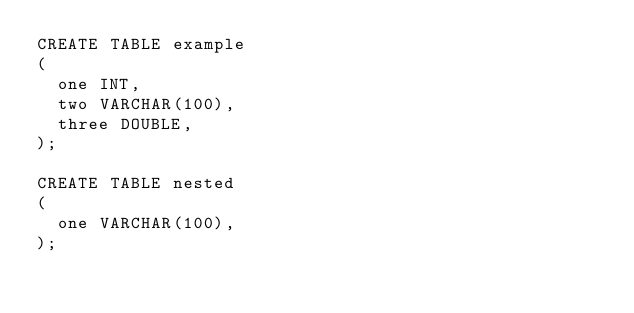Convert code to text. <code><loc_0><loc_0><loc_500><loc_500><_SQL_>CREATE TABLE example
(
  one INT,
  two VARCHAR(100),
  three DOUBLE,
);

CREATE TABLE nested
(
  one VARCHAR(100),
);
</code> 